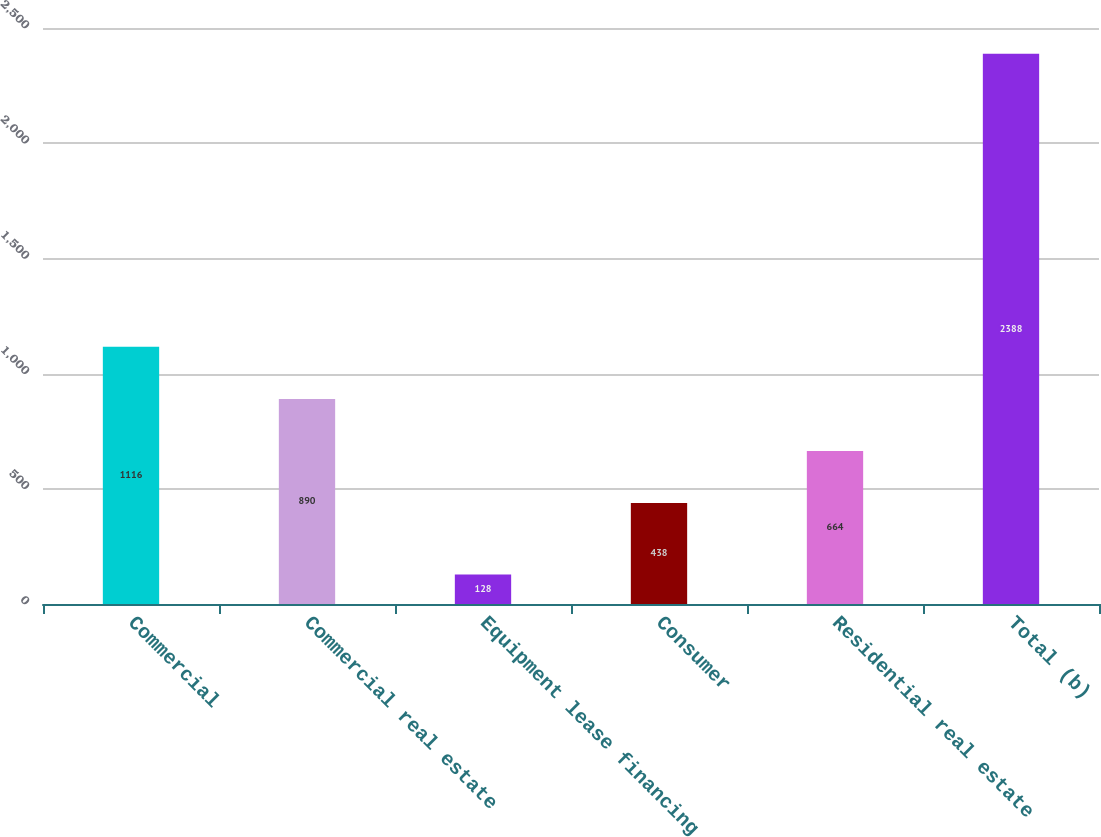<chart> <loc_0><loc_0><loc_500><loc_500><bar_chart><fcel>Commercial<fcel>Commercial real estate<fcel>Equipment lease financing<fcel>Consumer<fcel>Residential real estate<fcel>Total (b)<nl><fcel>1116<fcel>890<fcel>128<fcel>438<fcel>664<fcel>2388<nl></chart> 